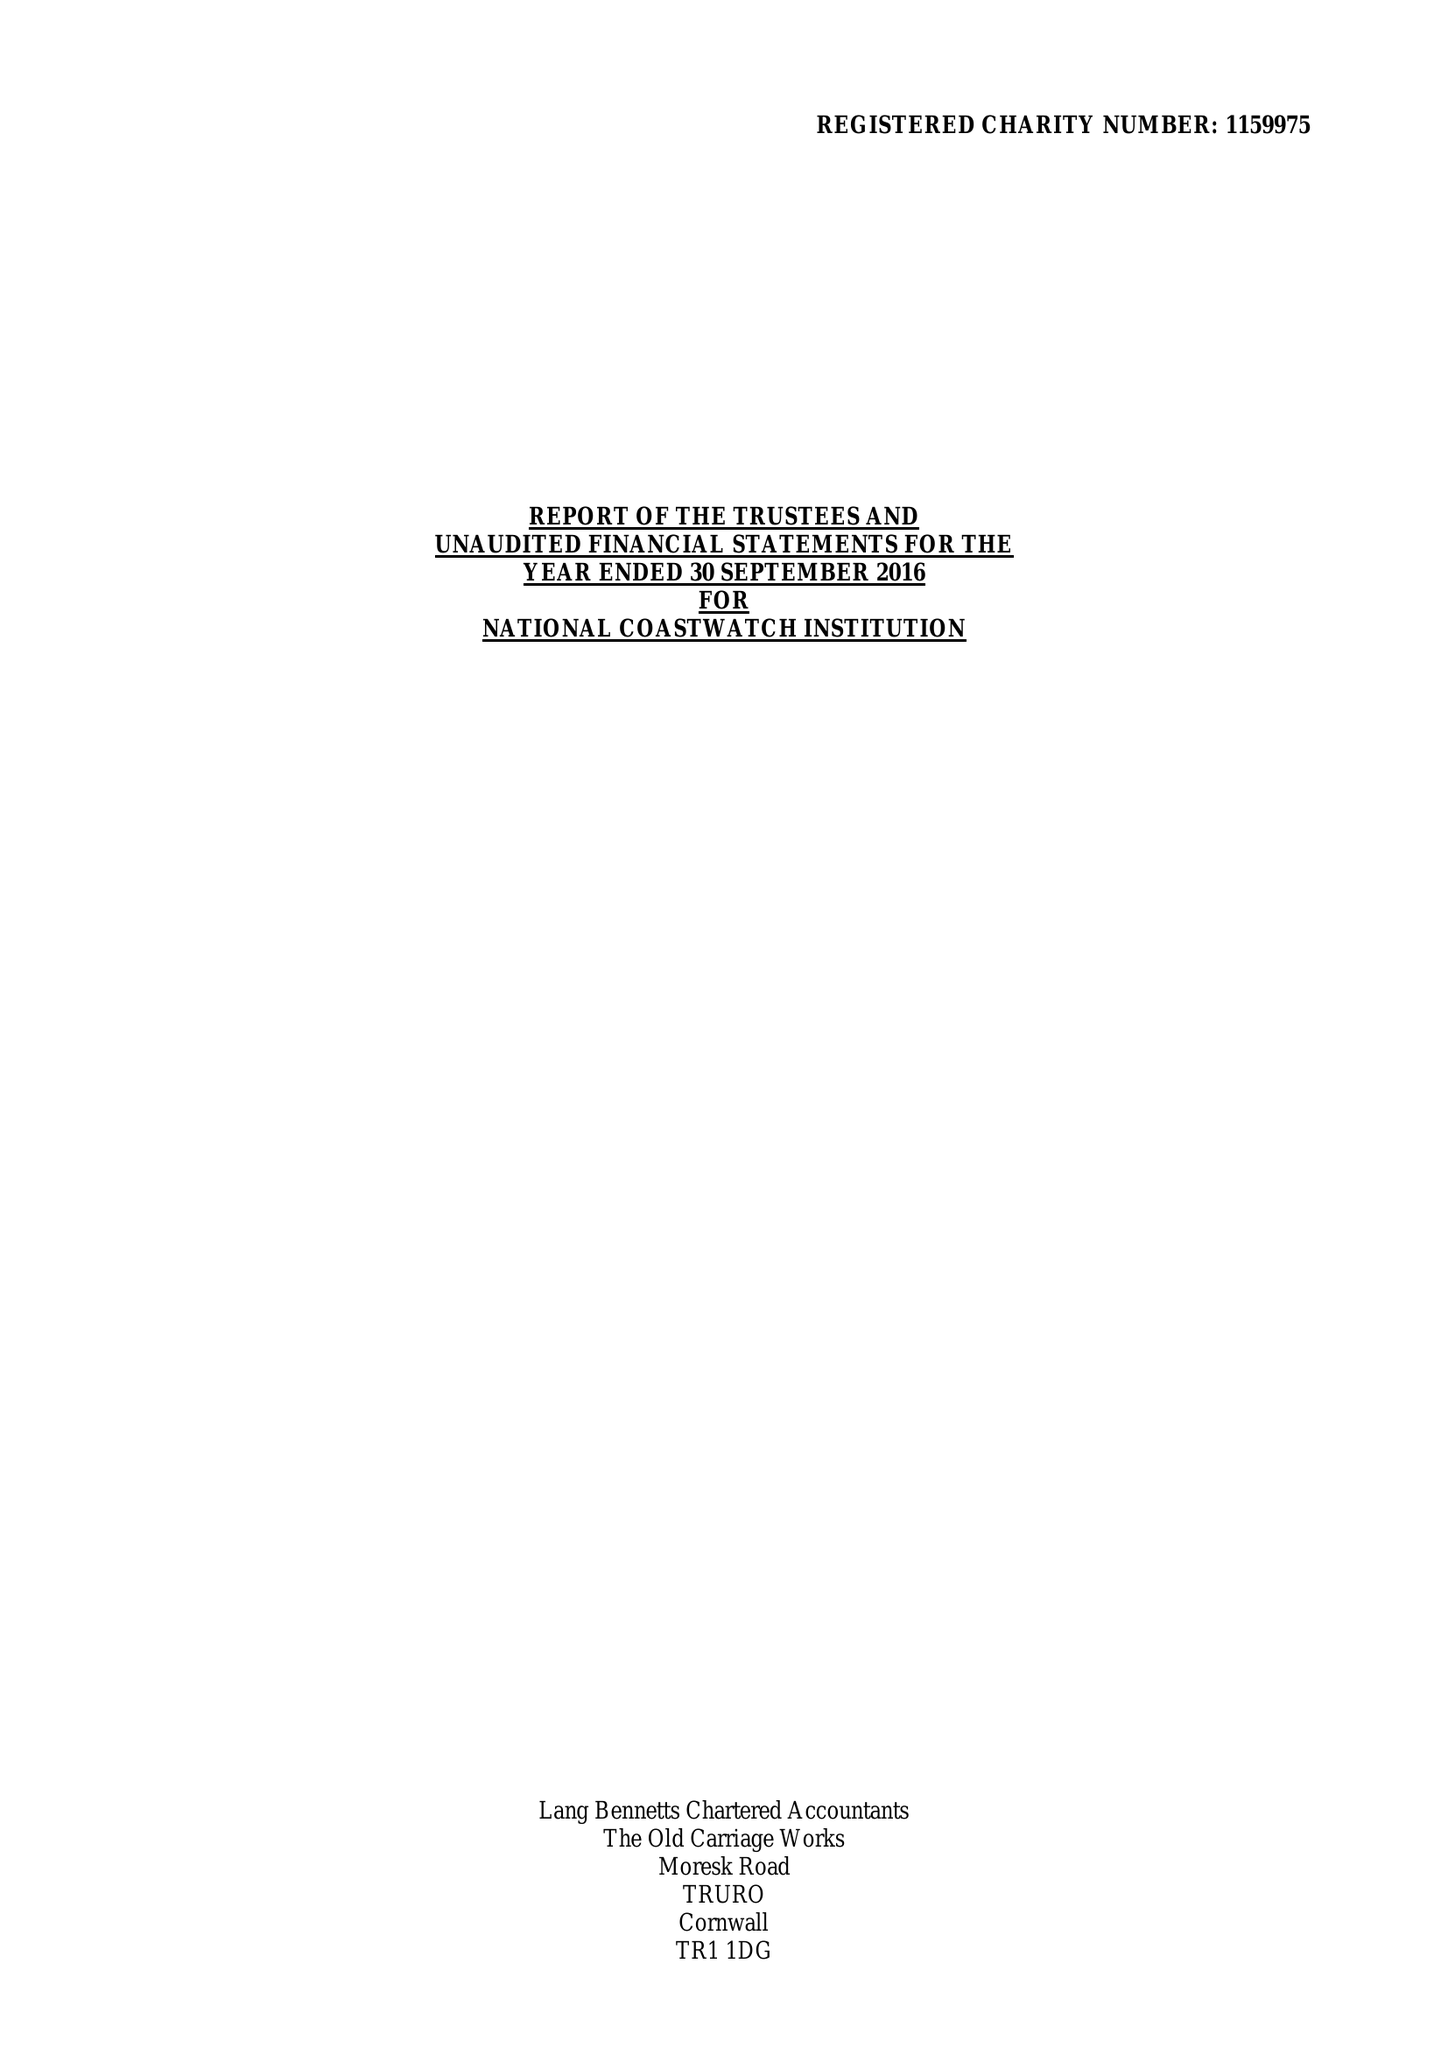What is the value for the spending_annually_in_british_pounds?
Answer the question using a single word or phrase. 525536.00 